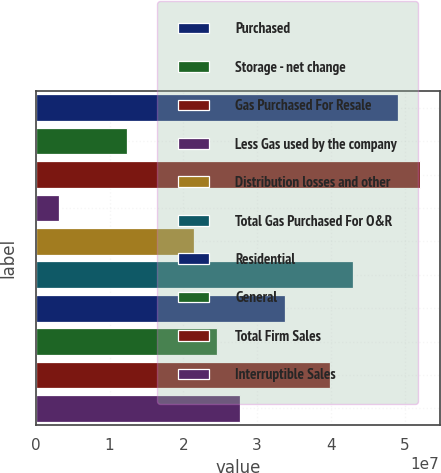<chart> <loc_0><loc_0><loc_500><loc_500><bar_chart><fcel>Purchased<fcel>Storage - net change<fcel>Gas Purchased For Resale<fcel>Less Gas used by the company<fcel>Distribution losses and other<fcel>Total Gas Purchased For O&R<fcel>Residential<fcel>General<fcel>Total Firm Sales<fcel>Interruptible Sales<nl><fcel>4.90586e+07<fcel>1.23049e+07<fcel>5.21215e+07<fcel>3.1165e+06<fcel>2.14934e+07<fcel>4.2933e+07<fcel>3.37446e+07<fcel>2.45562e+07<fcel>3.98702e+07<fcel>2.7619e+07<nl></chart> 